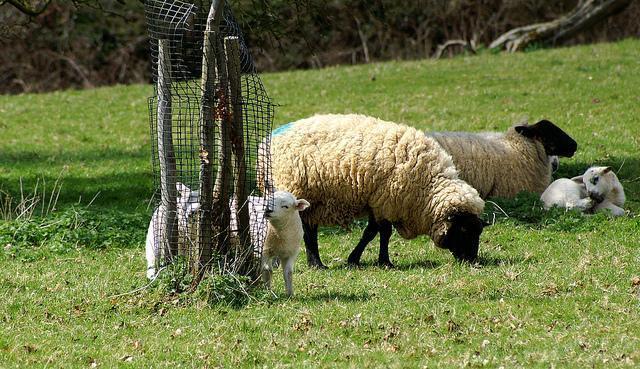How many sheep are depicted?
Give a very brief answer. 5. How many sheep can you see?
Give a very brief answer. 5. 